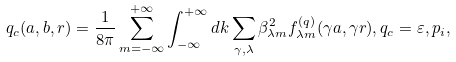Convert formula to latex. <formula><loc_0><loc_0><loc_500><loc_500>q _ { c } ( a , b , r ) = \frac { 1 } { 8 \pi } \sum _ { m = - \infty } ^ { + \infty } \int _ { - \infty } ^ { + \infty } d k \sum _ { \gamma , \lambda } \beta _ { \lambda m } ^ { 2 } f _ { \lambda m } ^ { ( q ) } ( \gamma a , \gamma r ) , q _ { c } = \varepsilon , p _ { i } ,</formula> 